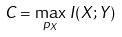<formula> <loc_0><loc_0><loc_500><loc_500>C = \max _ { p _ { X } } \, I ( X ; Y )</formula> 